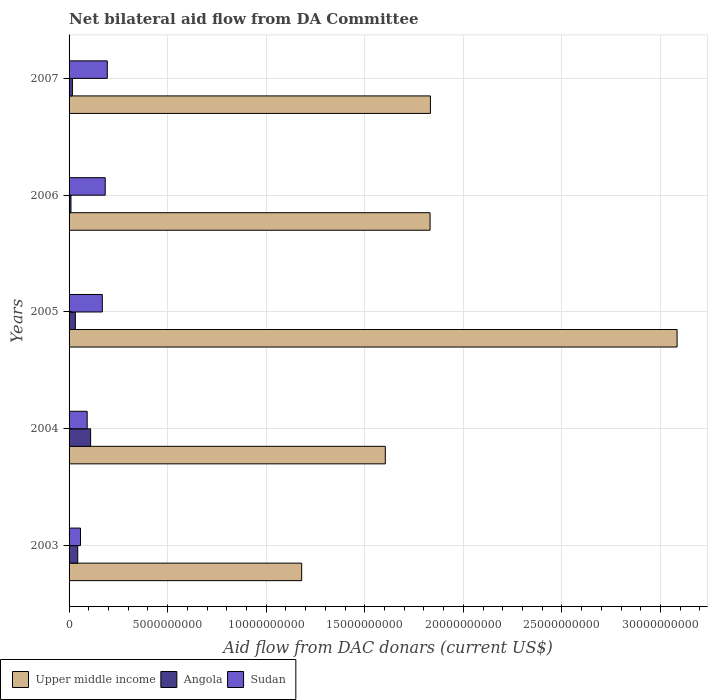How many different coloured bars are there?
Your answer should be very brief. 3. Are the number of bars per tick equal to the number of legend labels?
Provide a short and direct response. Yes. Are the number of bars on each tick of the Y-axis equal?
Your answer should be compact. Yes. How many bars are there on the 1st tick from the top?
Your answer should be very brief. 3. What is the label of the 1st group of bars from the top?
Make the answer very short. 2007. In how many cases, is the number of bars for a given year not equal to the number of legend labels?
Your answer should be very brief. 0. What is the aid flow in in Sudan in 2004?
Your answer should be compact. 9.18e+08. Across all years, what is the maximum aid flow in in Sudan?
Keep it short and to the point. 1.94e+09. Across all years, what is the minimum aid flow in in Upper middle income?
Keep it short and to the point. 1.18e+1. In which year was the aid flow in in Upper middle income maximum?
Keep it short and to the point. 2005. What is the total aid flow in in Upper middle income in the graph?
Ensure brevity in your answer.  9.53e+1. What is the difference between the aid flow in in Angola in 2006 and that in 2007?
Provide a succinct answer. -7.33e+07. What is the difference between the aid flow in in Sudan in 2004 and the aid flow in in Angola in 2007?
Your answer should be very brief. 7.48e+08. What is the average aid flow in in Angola per year?
Offer a terse response. 4.23e+08. In the year 2007, what is the difference between the aid flow in in Angola and aid flow in in Sudan?
Provide a succinct answer. -1.77e+09. What is the ratio of the aid flow in in Angola in 2003 to that in 2006?
Offer a very short reply. 4.55. Is the aid flow in in Angola in 2003 less than that in 2004?
Ensure brevity in your answer.  Yes. What is the difference between the highest and the second highest aid flow in in Sudan?
Your answer should be very brief. 1.06e+08. What is the difference between the highest and the lowest aid flow in in Sudan?
Keep it short and to the point. 1.36e+09. What does the 1st bar from the top in 2004 represents?
Your response must be concise. Sudan. What does the 3rd bar from the bottom in 2005 represents?
Provide a short and direct response. Sudan. Is it the case that in every year, the sum of the aid flow in in Upper middle income and aid flow in in Angola is greater than the aid flow in in Sudan?
Give a very brief answer. Yes. How many bars are there?
Your response must be concise. 15. Are the values on the major ticks of X-axis written in scientific E-notation?
Your response must be concise. No. Where does the legend appear in the graph?
Make the answer very short. Bottom left. How many legend labels are there?
Keep it short and to the point. 3. How are the legend labels stacked?
Your answer should be very brief. Horizontal. What is the title of the graph?
Offer a terse response. Net bilateral aid flow from DA Committee. What is the label or title of the X-axis?
Make the answer very short. Aid flow from DAC donars (current US$). What is the Aid flow from DAC donars (current US$) in Upper middle income in 2003?
Offer a very short reply. 1.18e+1. What is the Aid flow from DAC donars (current US$) in Angola in 2003?
Ensure brevity in your answer.  4.40e+08. What is the Aid flow from DAC donars (current US$) in Sudan in 2003?
Your response must be concise. 5.79e+08. What is the Aid flow from DAC donars (current US$) of Upper middle income in 2004?
Offer a terse response. 1.60e+1. What is the Aid flow from DAC donars (current US$) of Angola in 2004?
Ensure brevity in your answer.  1.09e+09. What is the Aid flow from DAC donars (current US$) in Sudan in 2004?
Your answer should be very brief. 9.18e+08. What is the Aid flow from DAC donars (current US$) of Upper middle income in 2005?
Your response must be concise. 3.08e+1. What is the Aid flow from DAC donars (current US$) in Angola in 2005?
Give a very brief answer. 3.19e+08. What is the Aid flow from DAC donars (current US$) in Sudan in 2005?
Your answer should be very brief. 1.69e+09. What is the Aid flow from DAC donars (current US$) of Upper middle income in 2006?
Your answer should be very brief. 1.83e+1. What is the Aid flow from DAC donars (current US$) of Angola in 2006?
Give a very brief answer. 9.66e+07. What is the Aid flow from DAC donars (current US$) of Sudan in 2006?
Provide a short and direct response. 1.83e+09. What is the Aid flow from DAC donars (current US$) in Upper middle income in 2007?
Offer a terse response. 1.83e+1. What is the Aid flow from DAC donars (current US$) of Angola in 2007?
Keep it short and to the point. 1.70e+08. What is the Aid flow from DAC donars (current US$) of Sudan in 2007?
Your answer should be compact. 1.94e+09. Across all years, what is the maximum Aid flow from DAC donars (current US$) in Upper middle income?
Offer a terse response. 3.08e+1. Across all years, what is the maximum Aid flow from DAC donars (current US$) of Angola?
Keep it short and to the point. 1.09e+09. Across all years, what is the maximum Aid flow from DAC donars (current US$) of Sudan?
Your answer should be very brief. 1.94e+09. Across all years, what is the minimum Aid flow from DAC donars (current US$) of Upper middle income?
Give a very brief answer. 1.18e+1. Across all years, what is the minimum Aid flow from DAC donars (current US$) in Angola?
Provide a succinct answer. 9.66e+07. Across all years, what is the minimum Aid flow from DAC donars (current US$) in Sudan?
Provide a succinct answer. 5.79e+08. What is the total Aid flow from DAC donars (current US$) in Upper middle income in the graph?
Keep it short and to the point. 9.53e+1. What is the total Aid flow from DAC donars (current US$) in Angola in the graph?
Your answer should be very brief. 2.12e+09. What is the total Aid flow from DAC donars (current US$) of Sudan in the graph?
Keep it short and to the point. 6.96e+09. What is the difference between the Aid flow from DAC donars (current US$) of Upper middle income in 2003 and that in 2004?
Your answer should be very brief. -4.24e+09. What is the difference between the Aid flow from DAC donars (current US$) of Angola in 2003 and that in 2004?
Give a very brief answer. -6.53e+08. What is the difference between the Aid flow from DAC donars (current US$) in Sudan in 2003 and that in 2004?
Provide a succinct answer. -3.39e+08. What is the difference between the Aid flow from DAC donars (current US$) in Upper middle income in 2003 and that in 2005?
Your answer should be compact. -1.90e+1. What is the difference between the Aid flow from DAC donars (current US$) in Angola in 2003 and that in 2005?
Provide a succinct answer. 1.21e+08. What is the difference between the Aid flow from DAC donars (current US$) in Sudan in 2003 and that in 2005?
Your answer should be very brief. -1.11e+09. What is the difference between the Aid flow from DAC donars (current US$) of Upper middle income in 2003 and that in 2006?
Make the answer very short. -6.51e+09. What is the difference between the Aid flow from DAC donars (current US$) of Angola in 2003 and that in 2006?
Your answer should be very brief. 3.43e+08. What is the difference between the Aid flow from DAC donars (current US$) of Sudan in 2003 and that in 2006?
Keep it short and to the point. -1.25e+09. What is the difference between the Aid flow from DAC donars (current US$) in Upper middle income in 2003 and that in 2007?
Provide a succinct answer. -6.53e+09. What is the difference between the Aid flow from DAC donars (current US$) of Angola in 2003 and that in 2007?
Offer a very short reply. 2.70e+08. What is the difference between the Aid flow from DAC donars (current US$) in Sudan in 2003 and that in 2007?
Offer a very short reply. -1.36e+09. What is the difference between the Aid flow from DAC donars (current US$) of Upper middle income in 2004 and that in 2005?
Provide a short and direct response. -1.48e+1. What is the difference between the Aid flow from DAC donars (current US$) of Angola in 2004 and that in 2005?
Keep it short and to the point. 7.74e+08. What is the difference between the Aid flow from DAC donars (current US$) in Sudan in 2004 and that in 2005?
Your response must be concise. -7.68e+08. What is the difference between the Aid flow from DAC donars (current US$) in Upper middle income in 2004 and that in 2006?
Provide a succinct answer. -2.27e+09. What is the difference between the Aid flow from DAC donars (current US$) of Angola in 2004 and that in 2006?
Offer a very short reply. 9.96e+08. What is the difference between the Aid flow from DAC donars (current US$) in Sudan in 2004 and that in 2006?
Provide a succinct answer. -9.14e+08. What is the difference between the Aid flow from DAC donars (current US$) in Upper middle income in 2004 and that in 2007?
Your answer should be very brief. -2.29e+09. What is the difference between the Aid flow from DAC donars (current US$) in Angola in 2004 and that in 2007?
Offer a very short reply. 9.23e+08. What is the difference between the Aid flow from DAC donars (current US$) in Sudan in 2004 and that in 2007?
Provide a succinct answer. -1.02e+09. What is the difference between the Aid flow from DAC donars (current US$) in Upper middle income in 2005 and that in 2006?
Your answer should be very brief. 1.25e+1. What is the difference between the Aid flow from DAC donars (current US$) in Angola in 2005 and that in 2006?
Give a very brief answer. 2.22e+08. What is the difference between the Aid flow from DAC donars (current US$) in Sudan in 2005 and that in 2006?
Give a very brief answer. -1.47e+08. What is the difference between the Aid flow from DAC donars (current US$) of Upper middle income in 2005 and that in 2007?
Ensure brevity in your answer.  1.25e+1. What is the difference between the Aid flow from DAC donars (current US$) of Angola in 2005 and that in 2007?
Offer a terse response. 1.49e+08. What is the difference between the Aid flow from DAC donars (current US$) in Sudan in 2005 and that in 2007?
Your answer should be very brief. -2.53e+08. What is the difference between the Aid flow from DAC donars (current US$) in Upper middle income in 2006 and that in 2007?
Offer a very short reply. -1.82e+07. What is the difference between the Aid flow from DAC donars (current US$) of Angola in 2006 and that in 2007?
Your response must be concise. -7.33e+07. What is the difference between the Aid flow from DAC donars (current US$) of Sudan in 2006 and that in 2007?
Your answer should be compact. -1.06e+08. What is the difference between the Aid flow from DAC donars (current US$) in Upper middle income in 2003 and the Aid flow from DAC donars (current US$) in Angola in 2004?
Provide a short and direct response. 1.07e+1. What is the difference between the Aid flow from DAC donars (current US$) in Upper middle income in 2003 and the Aid flow from DAC donars (current US$) in Sudan in 2004?
Provide a succinct answer. 1.09e+1. What is the difference between the Aid flow from DAC donars (current US$) of Angola in 2003 and the Aid flow from DAC donars (current US$) of Sudan in 2004?
Your answer should be compact. -4.79e+08. What is the difference between the Aid flow from DAC donars (current US$) in Upper middle income in 2003 and the Aid flow from DAC donars (current US$) in Angola in 2005?
Your response must be concise. 1.15e+1. What is the difference between the Aid flow from DAC donars (current US$) in Upper middle income in 2003 and the Aid flow from DAC donars (current US$) in Sudan in 2005?
Offer a very short reply. 1.01e+1. What is the difference between the Aid flow from DAC donars (current US$) in Angola in 2003 and the Aid flow from DAC donars (current US$) in Sudan in 2005?
Your response must be concise. -1.25e+09. What is the difference between the Aid flow from DAC donars (current US$) in Upper middle income in 2003 and the Aid flow from DAC donars (current US$) in Angola in 2006?
Keep it short and to the point. 1.17e+1. What is the difference between the Aid flow from DAC donars (current US$) of Upper middle income in 2003 and the Aid flow from DAC donars (current US$) of Sudan in 2006?
Keep it short and to the point. 9.97e+09. What is the difference between the Aid flow from DAC donars (current US$) of Angola in 2003 and the Aid flow from DAC donars (current US$) of Sudan in 2006?
Offer a very short reply. -1.39e+09. What is the difference between the Aid flow from DAC donars (current US$) in Upper middle income in 2003 and the Aid flow from DAC donars (current US$) in Angola in 2007?
Ensure brevity in your answer.  1.16e+1. What is the difference between the Aid flow from DAC donars (current US$) of Upper middle income in 2003 and the Aid flow from DAC donars (current US$) of Sudan in 2007?
Make the answer very short. 9.86e+09. What is the difference between the Aid flow from DAC donars (current US$) of Angola in 2003 and the Aid flow from DAC donars (current US$) of Sudan in 2007?
Offer a terse response. -1.50e+09. What is the difference between the Aid flow from DAC donars (current US$) of Upper middle income in 2004 and the Aid flow from DAC donars (current US$) of Angola in 2005?
Provide a short and direct response. 1.57e+1. What is the difference between the Aid flow from DAC donars (current US$) of Upper middle income in 2004 and the Aid flow from DAC donars (current US$) of Sudan in 2005?
Offer a terse response. 1.44e+1. What is the difference between the Aid flow from DAC donars (current US$) in Angola in 2004 and the Aid flow from DAC donars (current US$) in Sudan in 2005?
Give a very brief answer. -5.93e+08. What is the difference between the Aid flow from DAC donars (current US$) of Upper middle income in 2004 and the Aid flow from DAC donars (current US$) of Angola in 2006?
Make the answer very short. 1.59e+1. What is the difference between the Aid flow from DAC donars (current US$) of Upper middle income in 2004 and the Aid flow from DAC donars (current US$) of Sudan in 2006?
Keep it short and to the point. 1.42e+1. What is the difference between the Aid flow from DAC donars (current US$) in Angola in 2004 and the Aid flow from DAC donars (current US$) in Sudan in 2006?
Your answer should be compact. -7.40e+08. What is the difference between the Aid flow from DAC donars (current US$) of Upper middle income in 2004 and the Aid flow from DAC donars (current US$) of Angola in 2007?
Provide a succinct answer. 1.59e+1. What is the difference between the Aid flow from DAC donars (current US$) in Upper middle income in 2004 and the Aid flow from DAC donars (current US$) in Sudan in 2007?
Provide a short and direct response. 1.41e+1. What is the difference between the Aid flow from DAC donars (current US$) of Angola in 2004 and the Aid flow from DAC donars (current US$) of Sudan in 2007?
Make the answer very short. -8.47e+08. What is the difference between the Aid flow from DAC donars (current US$) in Upper middle income in 2005 and the Aid flow from DAC donars (current US$) in Angola in 2006?
Offer a terse response. 3.07e+1. What is the difference between the Aid flow from DAC donars (current US$) of Upper middle income in 2005 and the Aid flow from DAC donars (current US$) of Sudan in 2006?
Your answer should be compact. 2.90e+1. What is the difference between the Aid flow from DAC donars (current US$) in Angola in 2005 and the Aid flow from DAC donars (current US$) in Sudan in 2006?
Give a very brief answer. -1.51e+09. What is the difference between the Aid flow from DAC donars (current US$) in Upper middle income in 2005 and the Aid flow from DAC donars (current US$) in Angola in 2007?
Offer a very short reply. 3.07e+1. What is the difference between the Aid flow from DAC donars (current US$) in Upper middle income in 2005 and the Aid flow from DAC donars (current US$) in Sudan in 2007?
Your answer should be very brief. 2.89e+1. What is the difference between the Aid flow from DAC donars (current US$) of Angola in 2005 and the Aid flow from DAC donars (current US$) of Sudan in 2007?
Provide a succinct answer. -1.62e+09. What is the difference between the Aid flow from DAC donars (current US$) in Upper middle income in 2006 and the Aid flow from DAC donars (current US$) in Angola in 2007?
Make the answer very short. 1.81e+1. What is the difference between the Aid flow from DAC donars (current US$) in Upper middle income in 2006 and the Aid flow from DAC donars (current US$) in Sudan in 2007?
Keep it short and to the point. 1.64e+1. What is the difference between the Aid flow from DAC donars (current US$) in Angola in 2006 and the Aid flow from DAC donars (current US$) in Sudan in 2007?
Give a very brief answer. -1.84e+09. What is the average Aid flow from DAC donars (current US$) of Upper middle income per year?
Keep it short and to the point. 1.91e+1. What is the average Aid flow from DAC donars (current US$) of Angola per year?
Keep it short and to the point. 4.23e+08. What is the average Aid flow from DAC donars (current US$) in Sudan per year?
Give a very brief answer. 1.39e+09. In the year 2003, what is the difference between the Aid flow from DAC donars (current US$) of Upper middle income and Aid flow from DAC donars (current US$) of Angola?
Ensure brevity in your answer.  1.14e+1. In the year 2003, what is the difference between the Aid flow from DAC donars (current US$) in Upper middle income and Aid flow from DAC donars (current US$) in Sudan?
Your answer should be very brief. 1.12e+1. In the year 2003, what is the difference between the Aid flow from DAC donars (current US$) in Angola and Aid flow from DAC donars (current US$) in Sudan?
Your response must be concise. -1.39e+08. In the year 2004, what is the difference between the Aid flow from DAC donars (current US$) in Upper middle income and Aid flow from DAC donars (current US$) in Angola?
Ensure brevity in your answer.  1.49e+1. In the year 2004, what is the difference between the Aid flow from DAC donars (current US$) of Upper middle income and Aid flow from DAC donars (current US$) of Sudan?
Your answer should be compact. 1.51e+1. In the year 2004, what is the difference between the Aid flow from DAC donars (current US$) in Angola and Aid flow from DAC donars (current US$) in Sudan?
Give a very brief answer. 1.74e+08. In the year 2005, what is the difference between the Aid flow from DAC donars (current US$) in Upper middle income and Aid flow from DAC donars (current US$) in Angola?
Make the answer very short. 3.05e+1. In the year 2005, what is the difference between the Aid flow from DAC donars (current US$) of Upper middle income and Aid flow from DAC donars (current US$) of Sudan?
Your response must be concise. 2.92e+1. In the year 2005, what is the difference between the Aid flow from DAC donars (current US$) of Angola and Aid flow from DAC donars (current US$) of Sudan?
Offer a terse response. -1.37e+09. In the year 2006, what is the difference between the Aid flow from DAC donars (current US$) in Upper middle income and Aid flow from DAC donars (current US$) in Angola?
Your response must be concise. 1.82e+1. In the year 2006, what is the difference between the Aid flow from DAC donars (current US$) of Upper middle income and Aid flow from DAC donars (current US$) of Sudan?
Your answer should be compact. 1.65e+1. In the year 2006, what is the difference between the Aid flow from DAC donars (current US$) in Angola and Aid flow from DAC donars (current US$) in Sudan?
Provide a succinct answer. -1.74e+09. In the year 2007, what is the difference between the Aid flow from DAC donars (current US$) of Upper middle income and Aid flow from DAC donars (current US$) of Angola?
Provide a succinct answer. 1.82e+1. In the year 2007, what is the difference between the Aid flow from DAC donars (current US$) in Upper middle income and Aid flow from DAC donars (current US$) in Sudan?
Your response must be concise. 1.64e+1. In the year 2007, what is the difference between the Aid flow from DAC donars (current US$) in Angola and Aid flow from DAC donars (current US$) in Sudan?
Make the answer very short. -1.77e+09. What is the ratio of the Aid flow from DAC donars (current US$) in Upper middle income in 2003 to that in 2004?
Keep it short and to the point. 0.74. What is the ratio of the Aid flow from DAC donars (current US$) in Angola in 2003 to that in 2004?
Ensure brevity in your answer.  0.4. What is the ratio of the Aid flow from DAC donars (current US$) of Sudan in 2003 to that in 2004?
Provide a succinct answer. 0.63. What is the ratio of the Aid flow from DAC donars (current US$) in Upper middle income in 2003 to that in 2005?
Give a very brief answer. 0.38. What is the ratio of the Aid flow from DAC donars (current US$) in Angola in 2003 to that in 2005?
Your answer should be compact. 1.38. What is the ratio of the Aid flow from DAC donars (current US$) of Sudan in 2003 to that in 2005?
Keep it short and to the point. 0.34. What is the ratio of the Aid flow from DAC donars (current US$) in Upper middle income in 2003 to that in 2006?
Offer a terse response. 0.64. What is the ratio of the Aid flow from DAC donars (current US$) in Angola in 2003 to that in 2006?
Your response must be concise. 4.55. What is the ratio of the Aid flow from DAC donars (current US$) of Sudan in 2003 to that in 2006?
Your answer should be very brief. 0.32. What is the ratio of the Aid flow from DAC donars (current US$) in Upper middle income in 2003 to that in 2007?
Offer a terse response. 0.64. What is the ratio of the Aid flow from DAC donars (current US$) in Angola in 2003 to that in 2007?
Offer a very short reply. 2.59. What is the ratio of the Aid flow from DAC donars (current US$) in Sudan in 2003 to that in 2007?
Ensure brevity in your answer.  0.3. What is the ratio of the Aid flow from DAC donars (current US$) of Upper middle income in 2004 to that in 2005?
Provide a succinct answer. 0.52. What is the ratio of the Aid flow from DAC donars (current US$) of Angola in 2004 to that in 2005?
Offer a very short reply. 3.43. What is the ratio of the Aid flow from DAC donars (current US$) in Sudan in 2004 to that in 2005?
Your response must be concise. 0.54. What is the ratio of the Aid flow from DAC donars (current US$) in Upper middle income in 2004 to that in 2006?
Give a very brief answer. 0.88. What is the ratio of the Aid flow from DAC donars (current US$) in Angola in 2004 to that in 2006?
Your response must be concise. 11.31. What is the ratio of the Aid flow from DAC donars (current US$) of Sudan in 2004 to that in 2006?
Ensure brevity in your answer.  0.5. What is the ratio of the Aid flow from DAC donars (current US$) of Upper middle income in 2004 to that in 2007?
Keep it short and to the point. 0.88. What is the ratio of the Aid flow from DAC donars (current US$) of Angola in 2004 to that in 2007?
Ensure brevity in your answer.  6.43. What is the ratio of the Aid flow from DAC donars (current US$) of Sudan in 2004 to that in 2007?
Provide a succinct answer. 0.47. What is the ratio of the Aid flow from DAC donars (current US$) in Upper middle income in 2005 to that in 2006?
Give a very brief answer. 1.68. What is the ratio of the Aid flow from DAC donars (current US$) of Angola in 2005 to that in 2006?
Your answer should be compact. 3.3. What is the ratio of the Aid flow from DAC donars (current US$) of Sudan in 2005 to that in 2006?
Make the answer very short. 0.92. What is the ratio of the Aid flow from DAC donars (current US$) in Upper middle income in 2005 to that in 2007?
Offer a very short reply. 1.68. What is the ratio of the Aid flow from DAC donars (current US$) of Angola in 2005 to that in 2007?
Give a very brief answer. 1.88. What is the ratio of the Aid flow from DAC donars (current US$) in Sudan in 2005 to that in 2007?
Ensure brevity in your answer.  0.87. What is the ratio of the Aid flow from DAC donars (current US$) of Angola in 2006 to that in 2007?
Offer a terse response. 0.57. What is the ratio of the Aid flow from DAC donars (current US$) in Sudan in 2006 to that in 2007?
Offer a very short reply. 0.95. What is the difference between the highest and the second highest Aid flow from DAC donars (current US$) of Upper middle income?
Give a very brief answer. 1.25e+1. What is the difference between the highest and the second highest Aid flow from DAC donars (current US$) of Angola?
Provide a succinct answer. 6.53e+08. What is the difference between the highest and the second highest Aid flow from DAC donars (current US$) in Sudan?
Your answer should be very brief. 1.06e+08. What is the difference between the highest and the lowest Aid flow from DAC donars (current US$) in Upper middle income?
Give a very brief answer. 1.90e+1. What is the difference between the highest and the lowest Aid flow from DAC donars (current US$) of Angola?
Give a very brief answer. 9.96e+08. What is the difference between the highest and the lowest Aid flow from DAC donars (current US$) of Sudan?
Your answer should be very brief. 1.36e+09. 